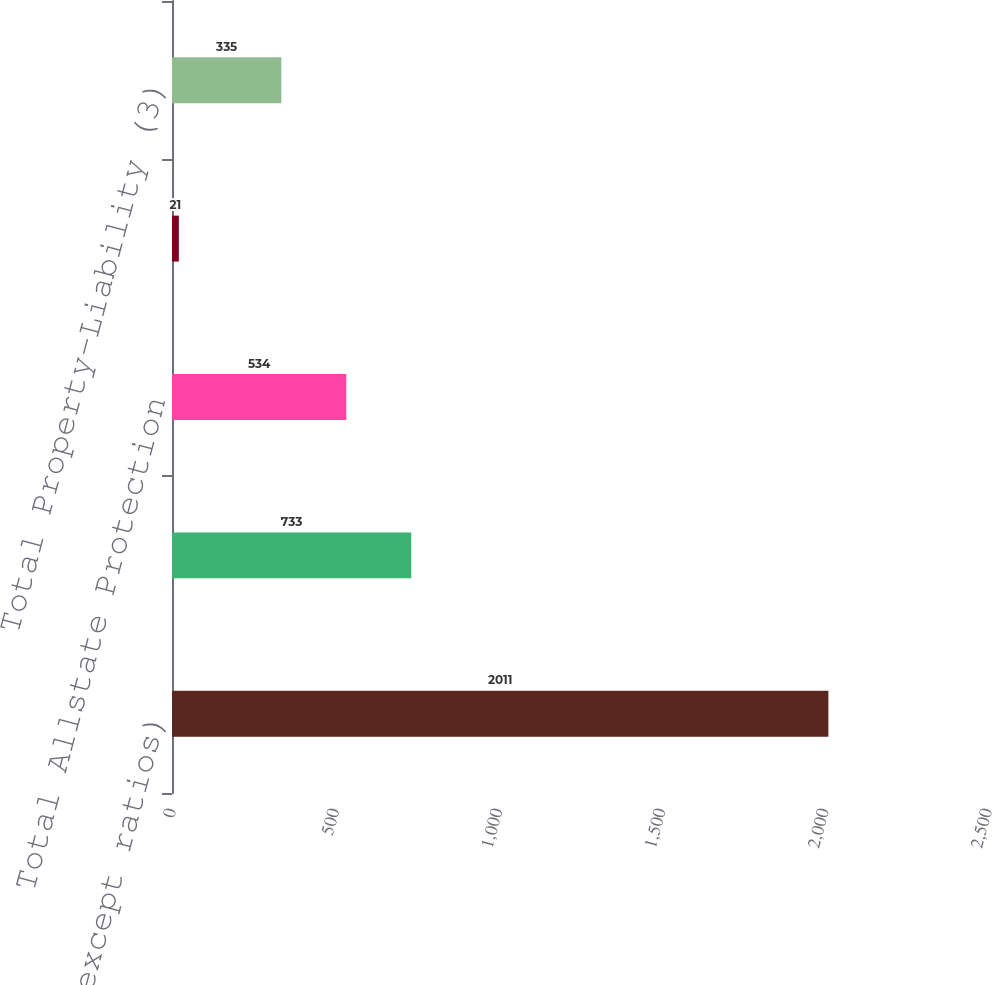<chart> <loc_0><loc_0><loc_500><loc_500><bar_chart><fcel>( in millions except ratios)<fcel>Allstate brand<fcel>Total Allstate Protection<fcel>Discontinued Lines and<fcel>Total Property-Liability (3)<nl><fcel>2011<fcel>733<fcel>534<fcel>21<fcel>335<nl></chart> 